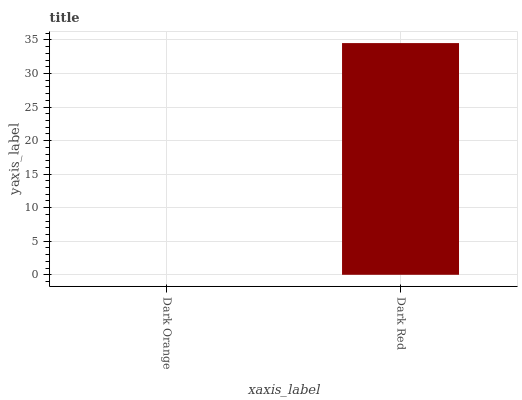Is Dark Orange the minimum?
Answer yes or no. Yes. Is Dark Red the maximum?
Answer yes or no. Yes. Is Dark Red the minimum?
Answer yes or no. No. Is Dark Red greater than Dark Orange?
Answer yes or no. Yes. Is Dark Orange less than Dark Red?
Answer yes or no. Yes. Is Dark Orange greater than Dark Red?
Answer yes or no. No. Is Dark Red less than Dark Orange?
Answer yes or no. No. Is Dark Red the high median?
Answer yes or no. Yes. Is Dark Orange the low median?
Answer yes or no. Yes. Is Dark Orange the high median?
Answer yes or no. No. Is Dark Red the low median?
Answer yes or no. No. 